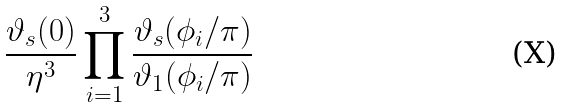<formula> <loc_0><loc_0><loc_500><loc_500>\frac { \vartheta _ { s } ( 0 ) } { \eta ^ { 3 } } \prod _ { i = 1 } ^ { 3 } \frac { \vartheta _ { s } ( \phi _ { i } / \pi ) } { \vartheta _ { 1 } ( \phi _ { i } / \pi ) }</formula> 